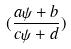Convert formula to latex. <formula><loc_0><loc_0><loc_500><loc_500>( \frac { a \psi + b } { c \psi + d } )</formula> 